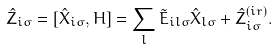<formula> <loc_0><loc_0><loc_500><loc_500>\hat { Z } _ { i \sigma } = [ \hat { X } _ { i \sigma } , H ] = \sum _ { l } \tilde { E } _ { i l \sigma } \hat { X } _ { l \sigma } + \hat { Z } _ { i \sigma } ^ { ( i r ) } .</formula> 